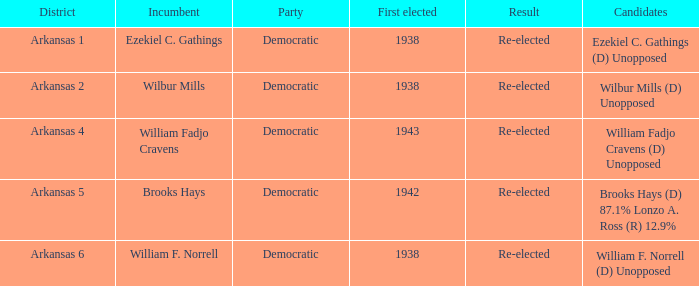What party did the incumbent of the Arkansas 6 district belong to?  Democratic. 